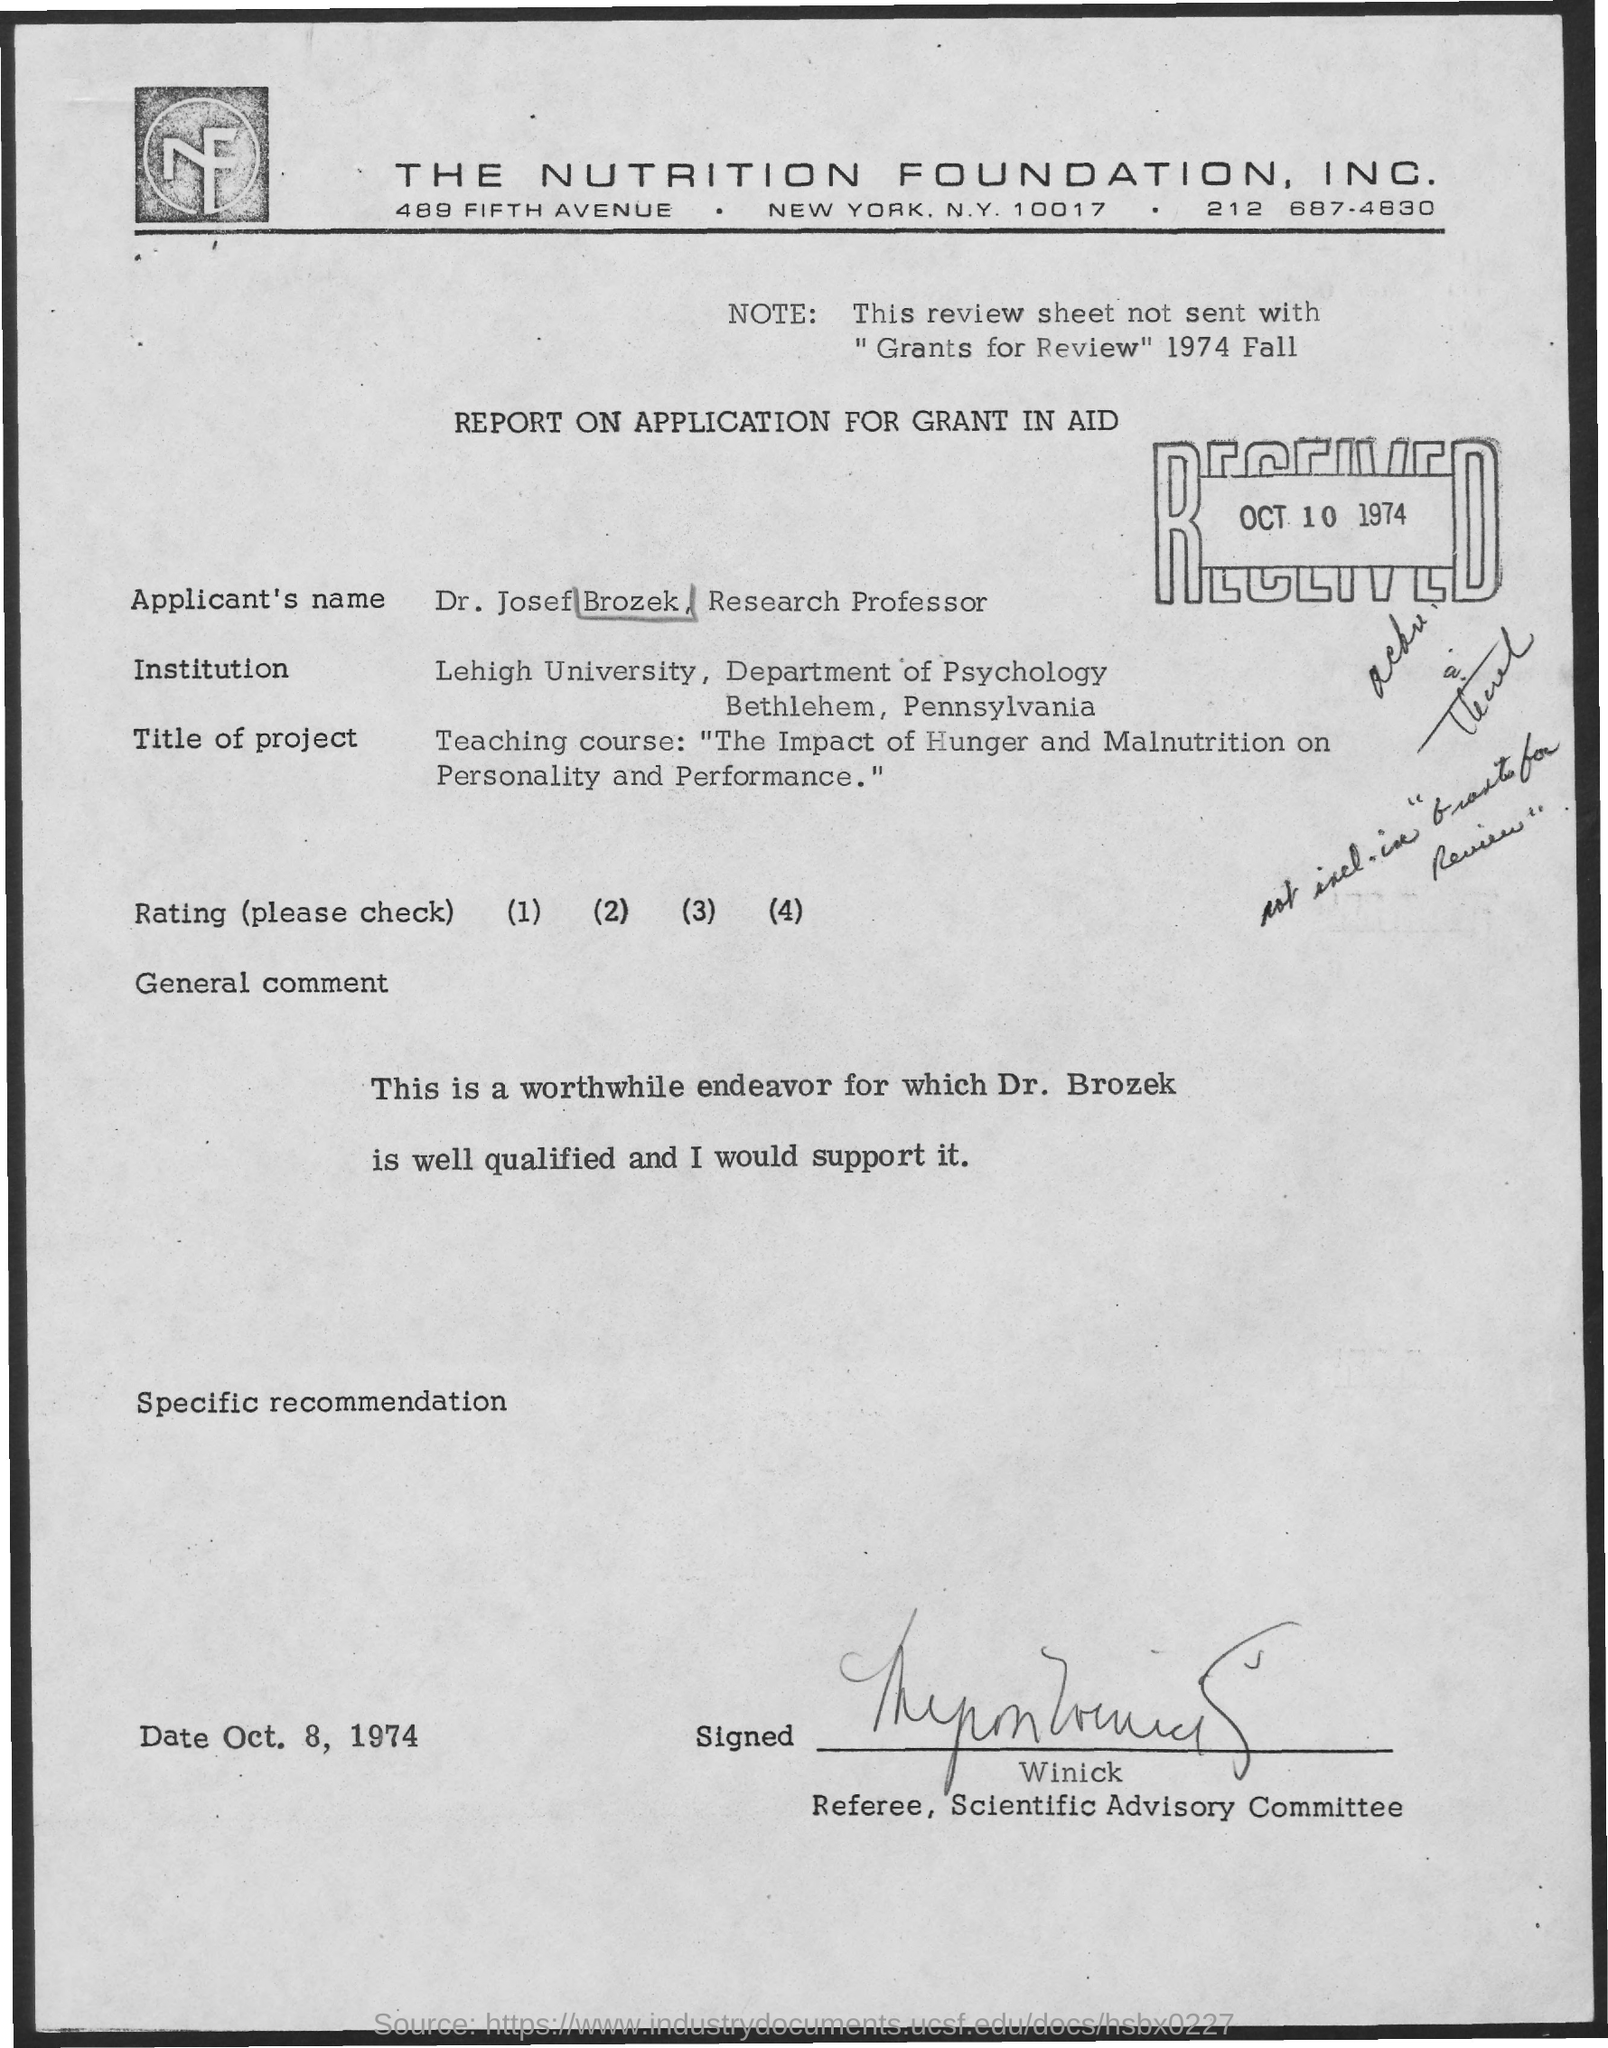Draw attention to some important aspects in this diagram. This note was written asking what the note being referred to is, as it was not included with the 'Grants for Review' note from 1974 Fall. The date mentioned on the right side of the report is October 10, 1974. 